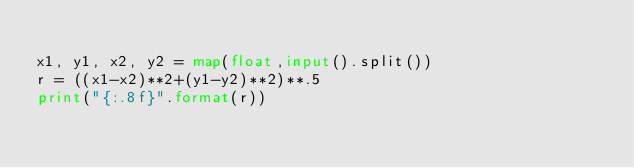<code> <loc_0><loc_0><loc_500><loc_500><_Python_>
x1, y1, x2, y2 = map(float,input().split())
r = ((x1-x2)**2+(y1-y2)**2)**.5
print("{:.8f}".format(r))
</code> 